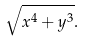Convert formula to latex. <formula><loc_0><loc_0><loc_500><loc_500>\sqrt { x ^ { 4 } + y ^ { 3 } } .</formula> 